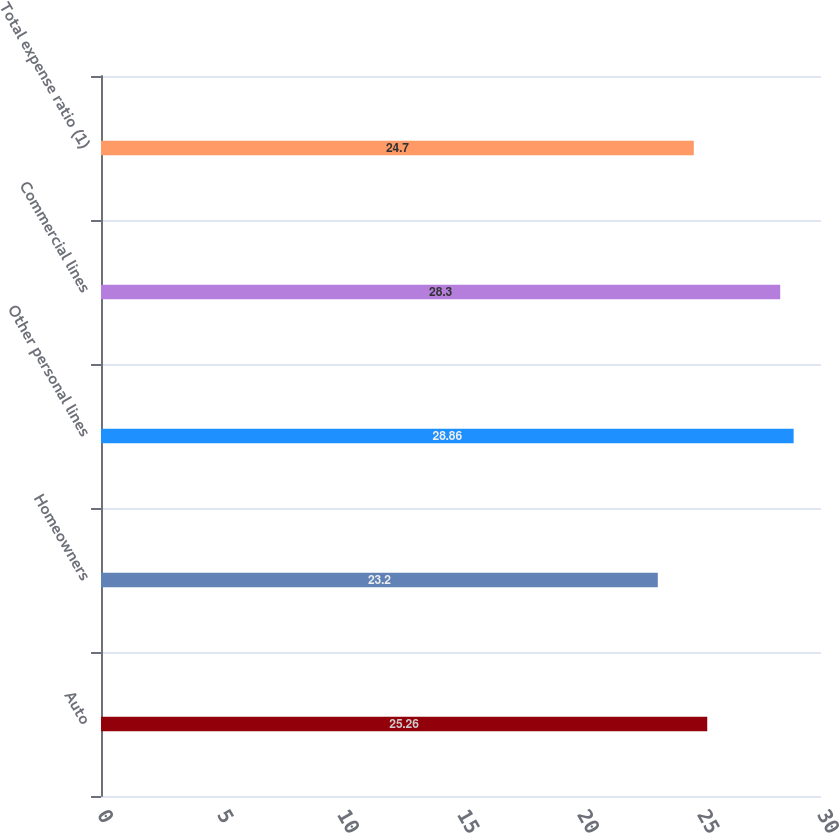Convert chart. <chart><loc_0><loc_0><loc_500><loc_500><bar_chart><fcel>Auto<fcel>Homeowners<fcel>Other personal lines<fcel>Commercial lines<fcel>Total expense ratio (1)<nl><fcel>25.26<fcel>23.2<fcel>28.86<fcel>28.3<fcel>24.7<nl></chart> 